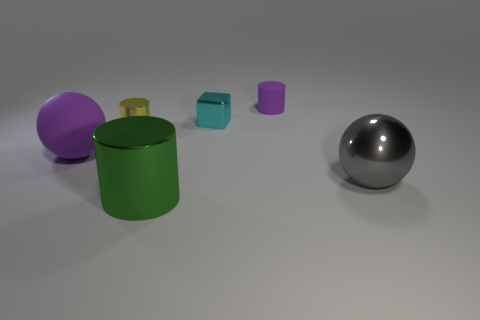There is a big thing that is the same color as the small rubber object; what is its shape?
Make the answer very short. Sphere. What number of large things are the same material as the small block?
Your answer should be compact. 2. Is the number of large spheres that are in front of the cyan metal block less than the number of big gray shiny objects?
Make the answer very short. No. What number of gray cylinders are there?
Offer a very short reply. 0. How many metal things have the same color as the small metallic cylinder?
Ensure brevity in your answer.  0. Does the yellow object have the same shape as the green object?
Keep it short and to the point. Yes. There is a metal cylinder that is to the left of the metallic object in front of the large gray object; what is its size?
Make the answer very short. Small. Is there a gray object that has the same size as the purple ball?
Make the answer very short. Yes. There is a metallic object that is on the right side of the cube; is its size the same as the sphere that is to the left of the large gray metallic sphere?
Your answer should be compact. Yes. The gray object that is right of the sphere that is on the left side of the gray metallic object is what shape?
Give a very brief answer. Sphere. 